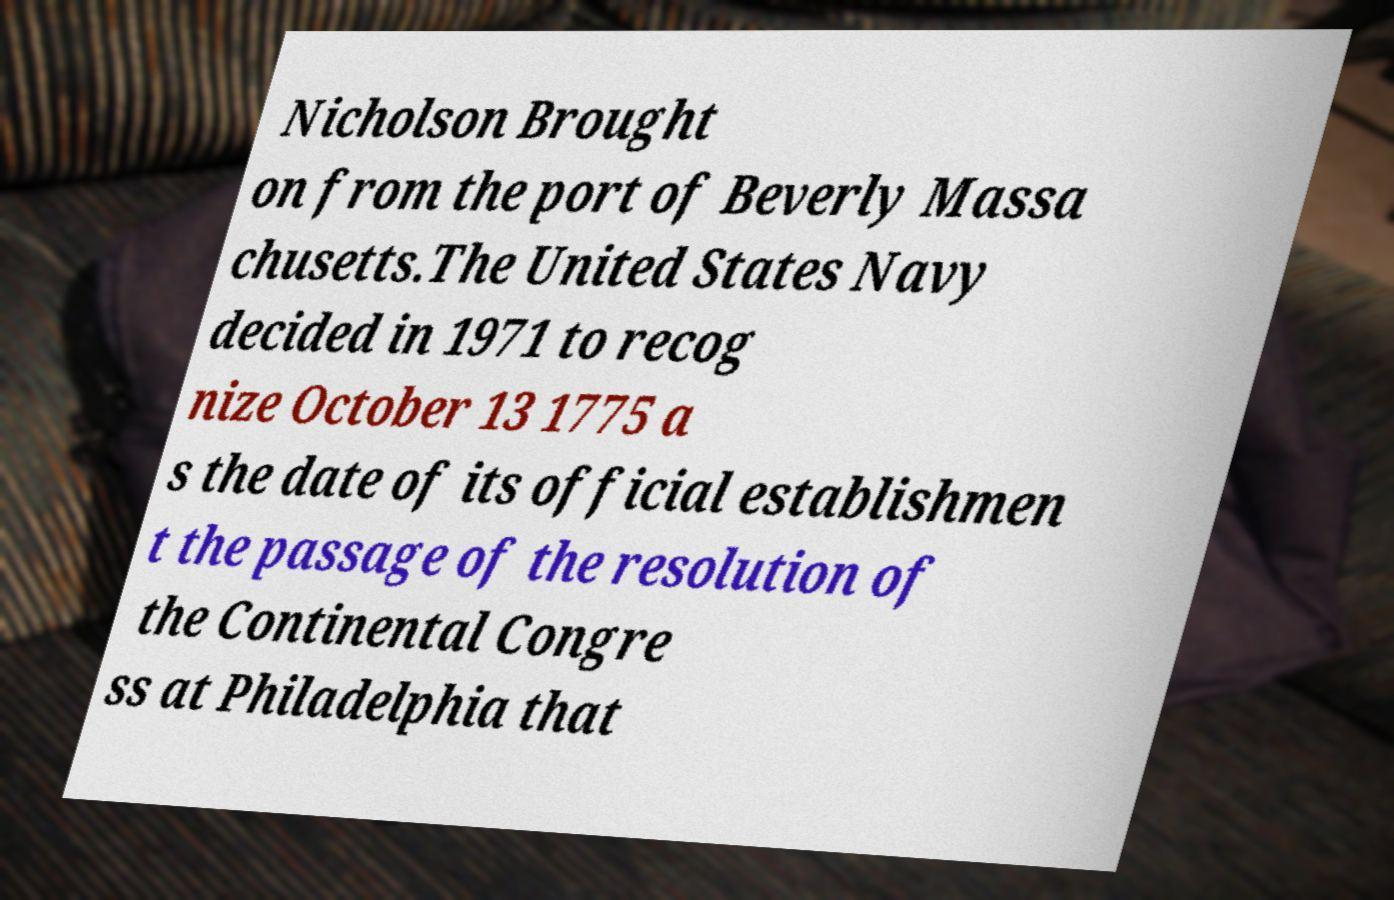Can you read and provide the text displayed in the image?This photo seems to have some interesting text. Can you extract and type it out for me? Nicholson Brought on from the port of Beverly Massa chusetts.The United States Navy decided in 1971 to recog nize October 13 1775 a s the date of its official establishmen t the passage of the resolution of the Continental Congre ss at Philadelphia that 